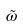Convert formula to latex. <formula><loc_0><loc_0><loc_500><loc_500>\tilde { \omega }</formula> 